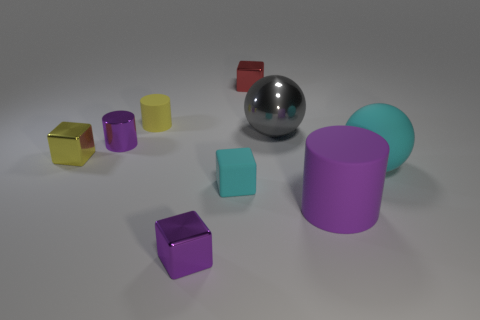How many objects in the image could be classified as geometric solids? All objects in the image can be classified as geometric solids. We have cubes, cylinders, and a sphere, which are all examples of solid geometric shapes. 